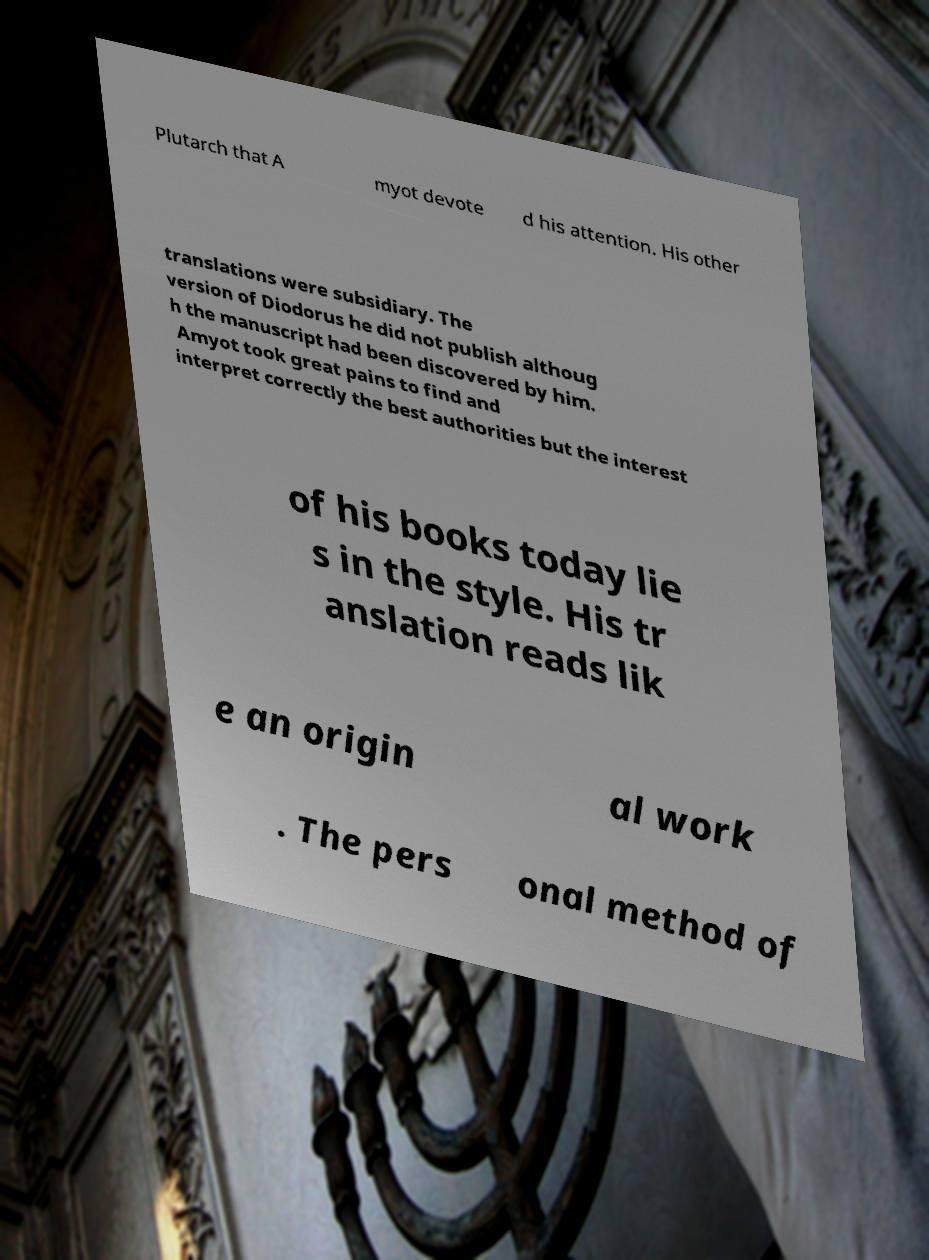I need the written content from this picture converted into text. Can you do that? Plutarch that A myot devote d his attention. His other translations were subsidiary. The version of Diodorus he did not publish althoug h the manuscript had been discovered by him. Amyot took great pains to find and interpret correctly the best authorities but the interest of his books today lie s in the style. His tr anslation reads lik e an origin al work . The pers onal method of 